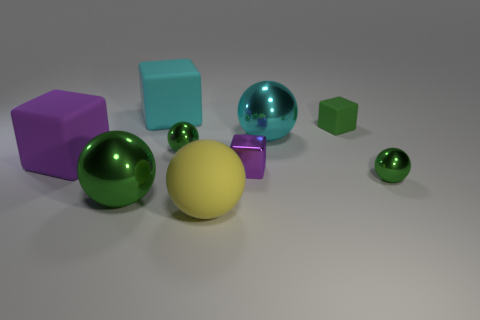There is a matte object that is the same color as the small shiny cube; what size is it?
Your answer should be very brief. Large. Is the number of green things behind the cyan rubber block greater than the number of green shiny balls?
Give a very brief answer. No. What shape is the green thing that is both right of the metallic block and in front of the tiny green rubber block?
Give a very brief answer. Sphere. Do the metal block and the cyan sphere have the same size?
Offer a terse response. No. There is a yellow ball; how many cyan spheres are to the left of it?
Offer a very short reply. 0. Are there the same number of metallic spheres right of the green rubber object and large cyan rubber objects in front of the large purple matte object?
Offer a terse response. No. Does the large shiny object to the left of the cyan matte object have the same shape as the big yellow thing?
Offer a very short reply. Yes. Is there anything else that has the same material as the small purple block?
Provide a short and direct response. Yes. There is a metal cube; does it have the same size as the cyan object on the left side of the large yellow ball?
Your answer should be very brief. No. What number of other objects are there of the same color as the metallic cube?
Provide a short and direct response. 1. 